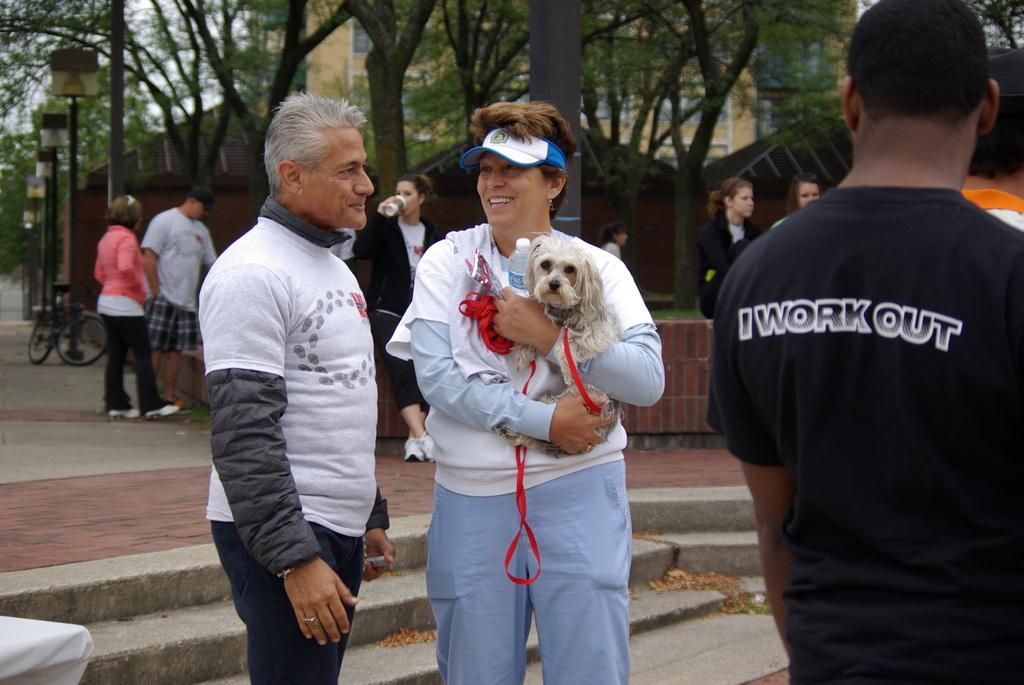In one or two sentences, can you explain what this image depicts? There are few people standing. This is a small puppy and a water bottle which is holded by the women. At background I can see a bicycle,street lights. These are the trees and building. This looks like a shelter. 